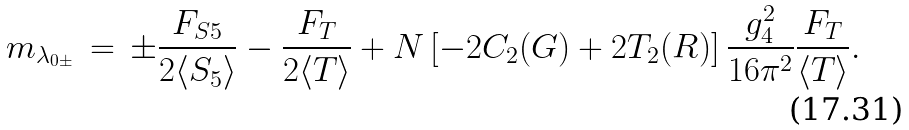Convert formula to latex. <formula><loc_0><loc_0><loc_500><loc_500>m _ { \lambda _ { 0 \pm } } \, = \, \pm \frac { F _ { S 5 } } { 2 \langle S _ { 5 } \rangle } - \frac { F _ { T } } { 2 \langle T \rangle } + N \left [ - 2 C _ { 2 } ( G ) + 2 T _ { 2 } ( R ) \right ] \frac { g _ { 4 } ^ { 2 } } { 1 6 \pi ^ { 2 } } \frac { F _ { T } } { \langle T \rangle } .</formula> 